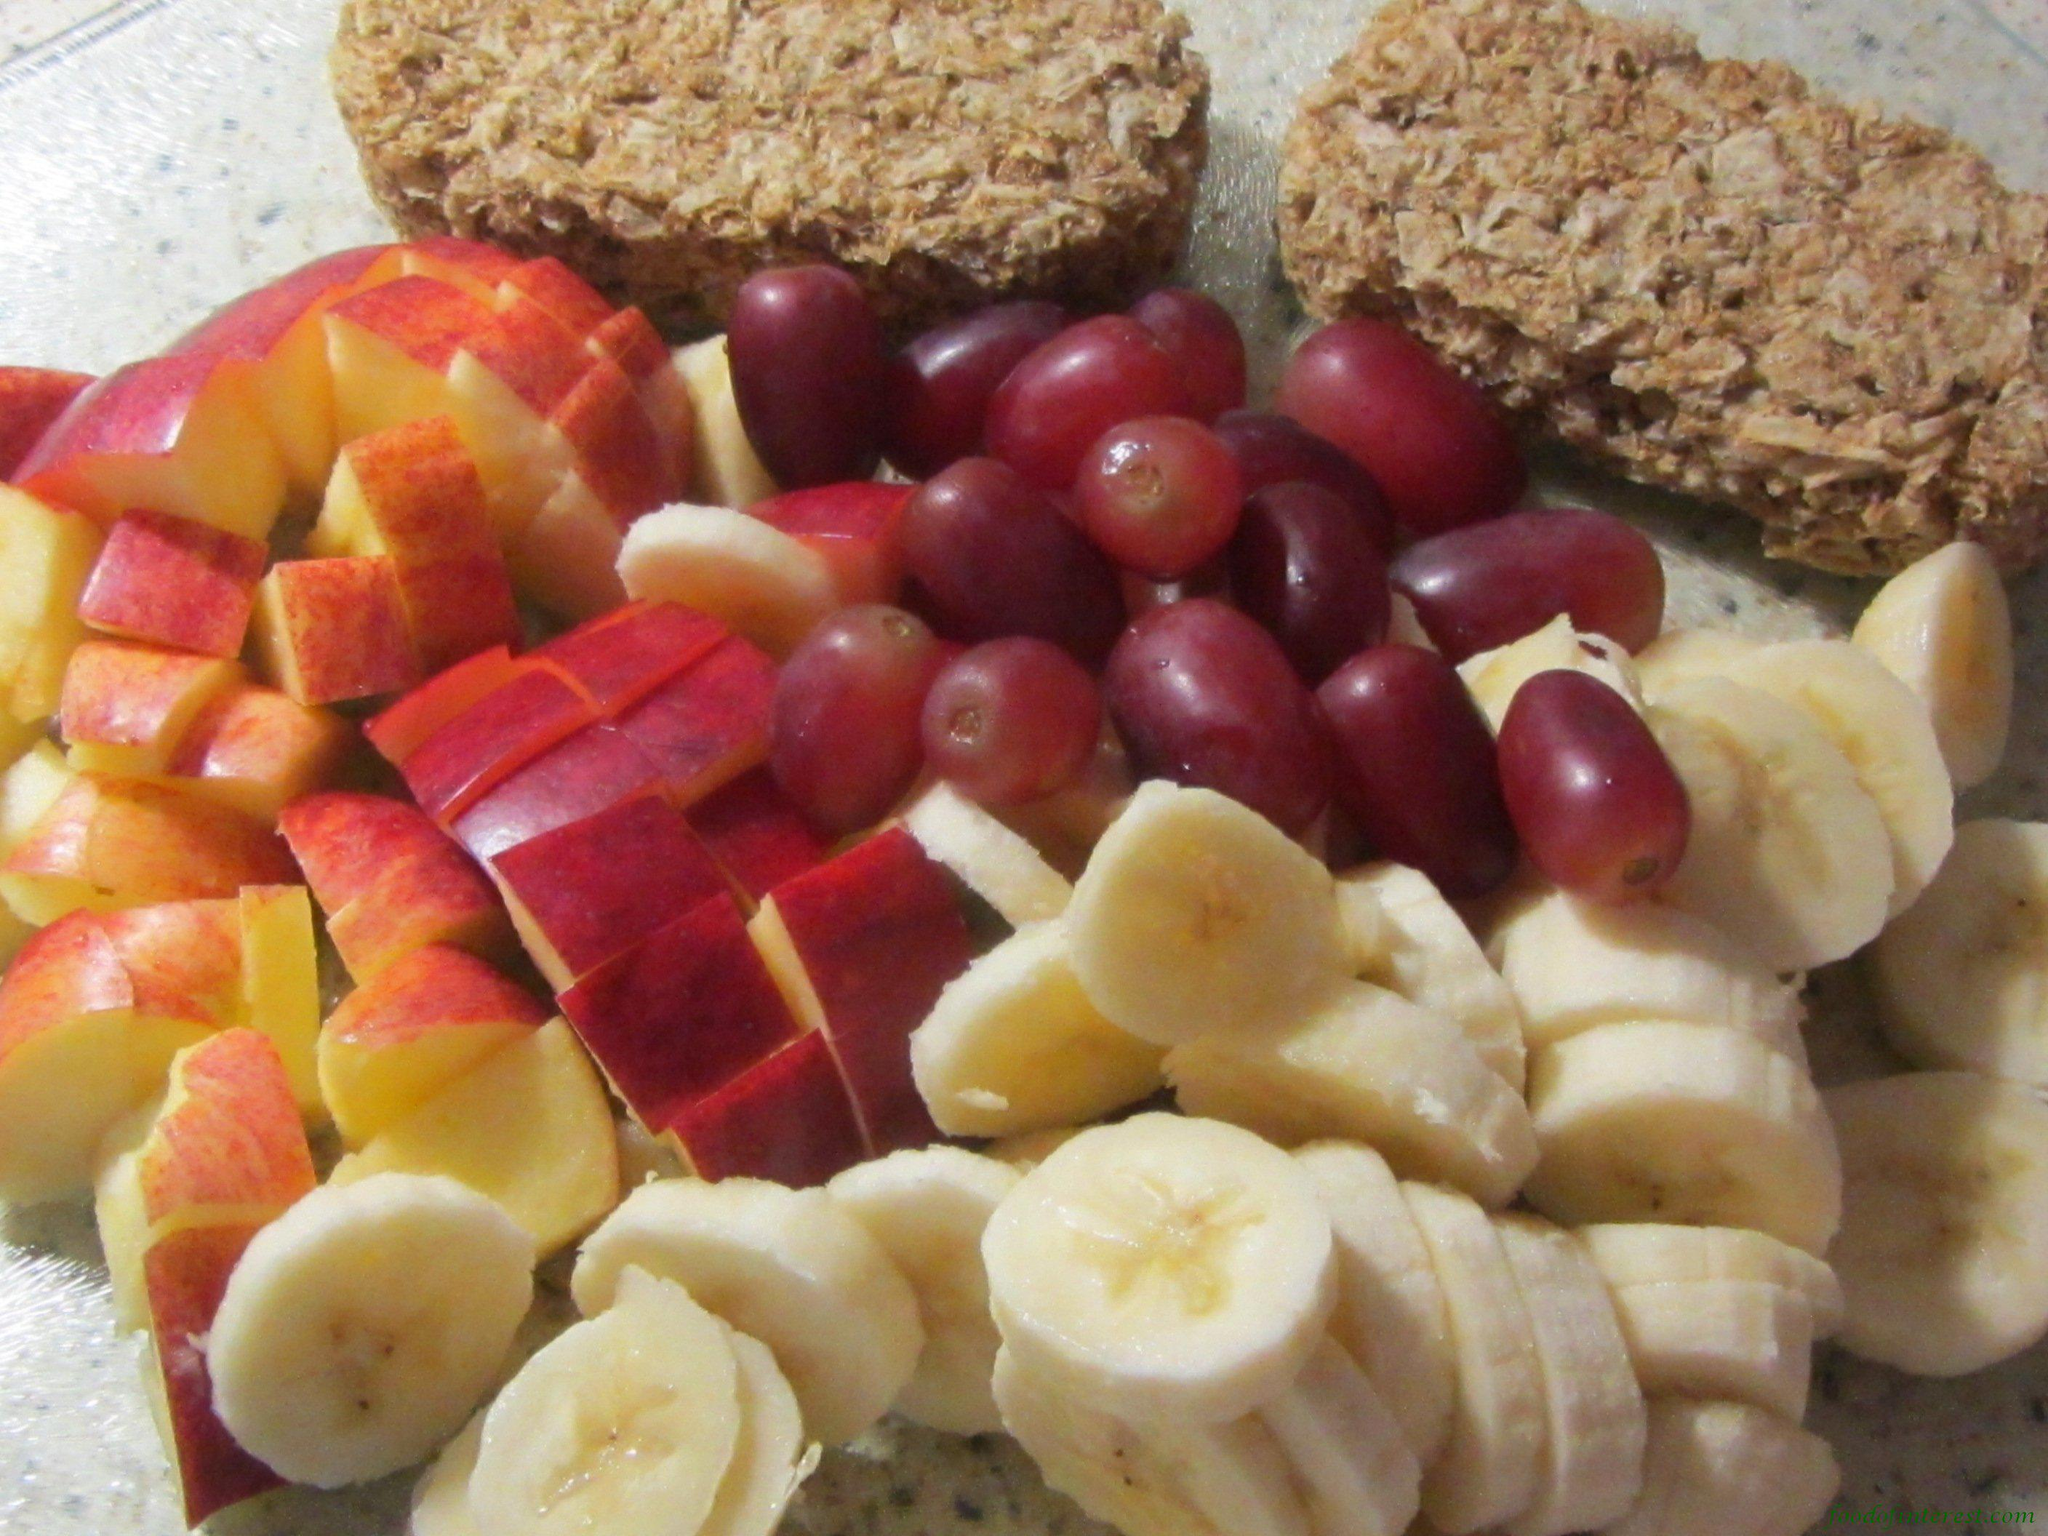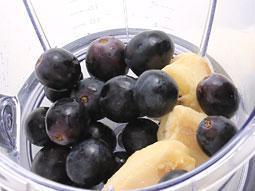The first image is the image on the left, the second image is the image on the right. For the images displayed, is the sentence "An image shows a basket filled with unpeeled bananas, green grapes, and reddish-purple plums." factually correct? Answer yes or no. No. The first image is the image on the left, the second image is the image on the right. Evaluate the accuracy of this statement regarding the images: "There are some sliced bananas.". Is it true? Answer yes or no. Yes. 